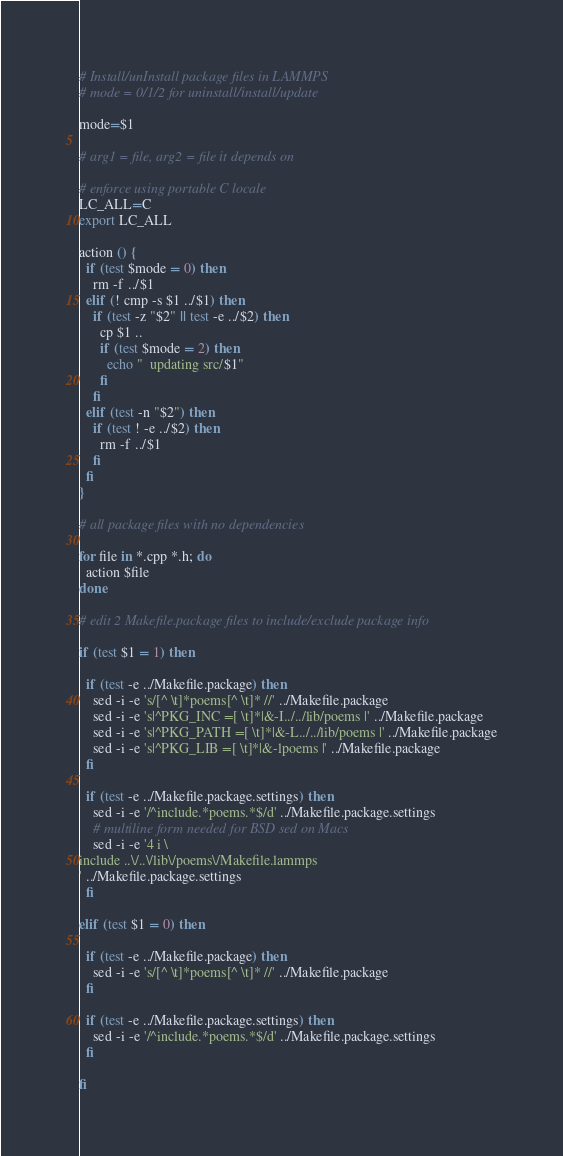<code> <loc_0><loc_0><loc_500><loc_500><_Bash_># Install/unInstall package files in LAMMPS
# mode = 0/1/2 for uninstall/install/update

mode=$1

# arg1 = file, arg2 = file it depends on

# enforce using portable C locale
LC_ALL=C
export LC_ALL

action () {
  if (test $mode = 0) then
    rm -f ../$1
  elif (! cmp -s $1 ../$1) then
    if (test -z "$2" || test -e ../$2) then
      cp $1 ..
      if (test $mode = 2) then
        echo "  updating src/$1"
      fi
    fi
  elif (test -n "$2") then
    if (test ! -e ../$2) then
      rm -f ../$1
    fi
  fi
}

# all package files with no dependencies

for file in *.cpp *.h; do
  action $file
done

# edit 2 Makefile.package files to include/exclude package info

if (test $1 = 1) then

  if (test -e ../Makefile.package) then
    sed -i -e 's/[^ \t]*poems[^ \t]* //' ../Makefile.package
    sed -i -e 's|^PKG_INC =[ \t]*|&-I../../lib/poems |' ../Makefile.package
    sed -i -e 's|^PKG_PATH =[ \t]*|&-L../../lib/poems |' ../Makefile.package
    sed -i -e 's|^PKG_LIB =[ \t]*|&-lpoems |' ../Makefile.package
  fi

  if (test -e ../Makefile.package.settings) then
    sed -i -e '/^include.*poems.*$/d' ../Makefile.package.settings
    # multiline form needed for BSD sed on Macs
    sed -i -e '4 i \
include ..\/..\/lib\/poems\/Makefile.lammps
' ../Makefile.package.settings
  fi

elif (test $1 = 0) then

  if (test -e ../Makefile.package) then
    sed -i -e 's/[^ \t]*poems[^ \t]* //' ../Makefile.package
  fi

  if (test -e ../Makefile.package.settings) then
    sed -i -e '/^include.*poems.*$/d' ../Makefile.package.settings
  fi

fi
</code> 